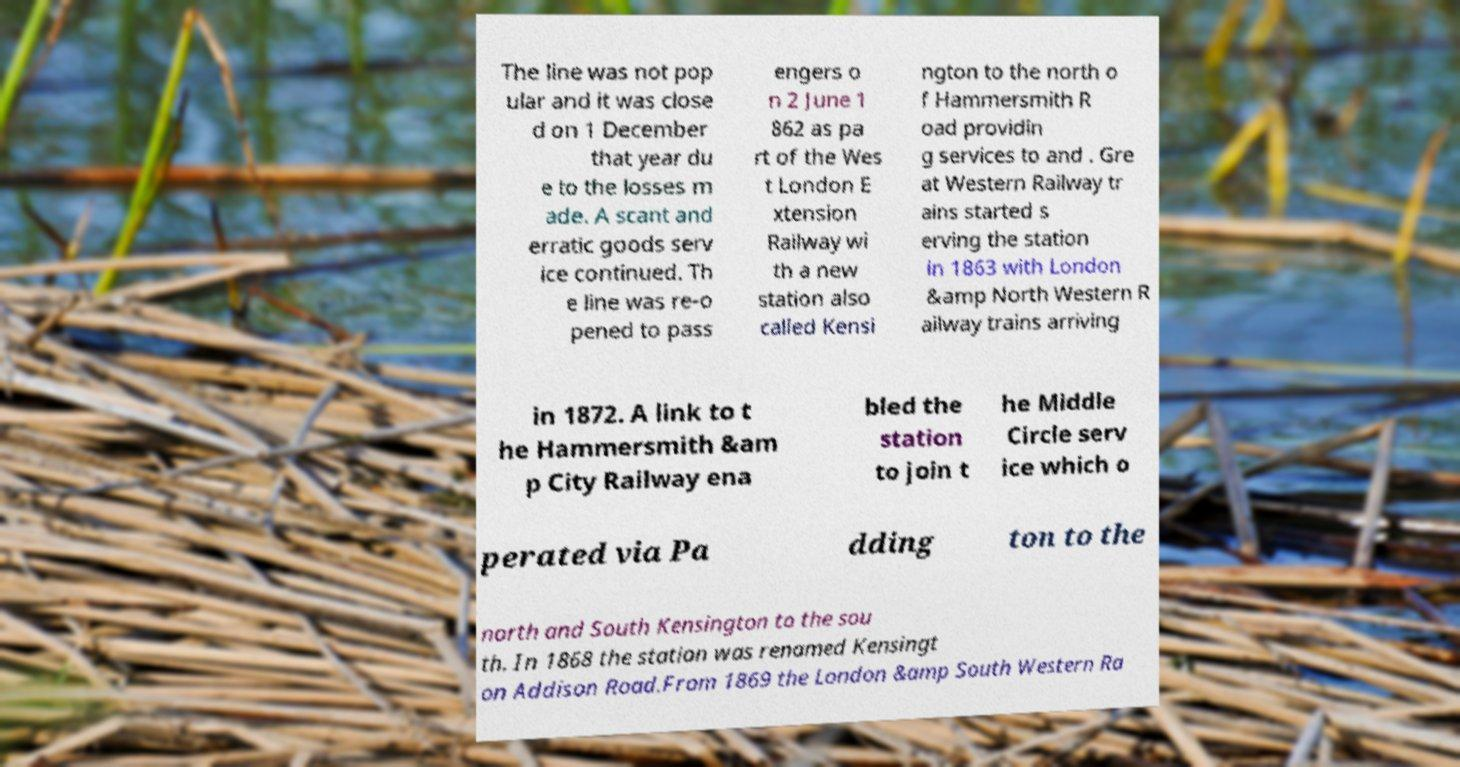I need the written content from this picture converted into text. Can you do that? The line was not pop ular and it was close d on 1 December that year du e to the losses m ade. A scant and erratic goods serv ice continued. Th e line was re-o pened to pass engers o n 2 June 1 862 as pa rt of the Wes t London E xtension Railway wi th a new station also called Kensi ngton to the north o f Hammersmith R oad providin g services to and . Gre at Western Railway tr ains started s erving the station in 1863 with London &amp North Western R ailway trains arriving in 1872. A link to t he Hammersmith &am p City Railway ena bled the station to join t he Middle Circle serv ice which o perated via Pa dding ton to the north and South Kensington to the sou th. In 1868 the station was renamed Kensingt on Addison Road.From 1869 the London &amp South Western Ra 